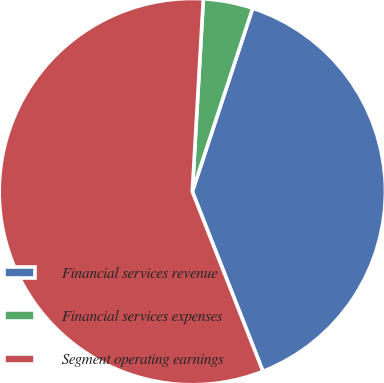Convert chart. <chart><loc_0><loc_0><loc_500><loc_500><pie_chart><fcel>Financial services revenue<fcel>Financial services expenses<fcel>Segment operating earnings<nl><fcel>38.98%<fcel>4.15%<fcel>56.87%<nl></chart> 